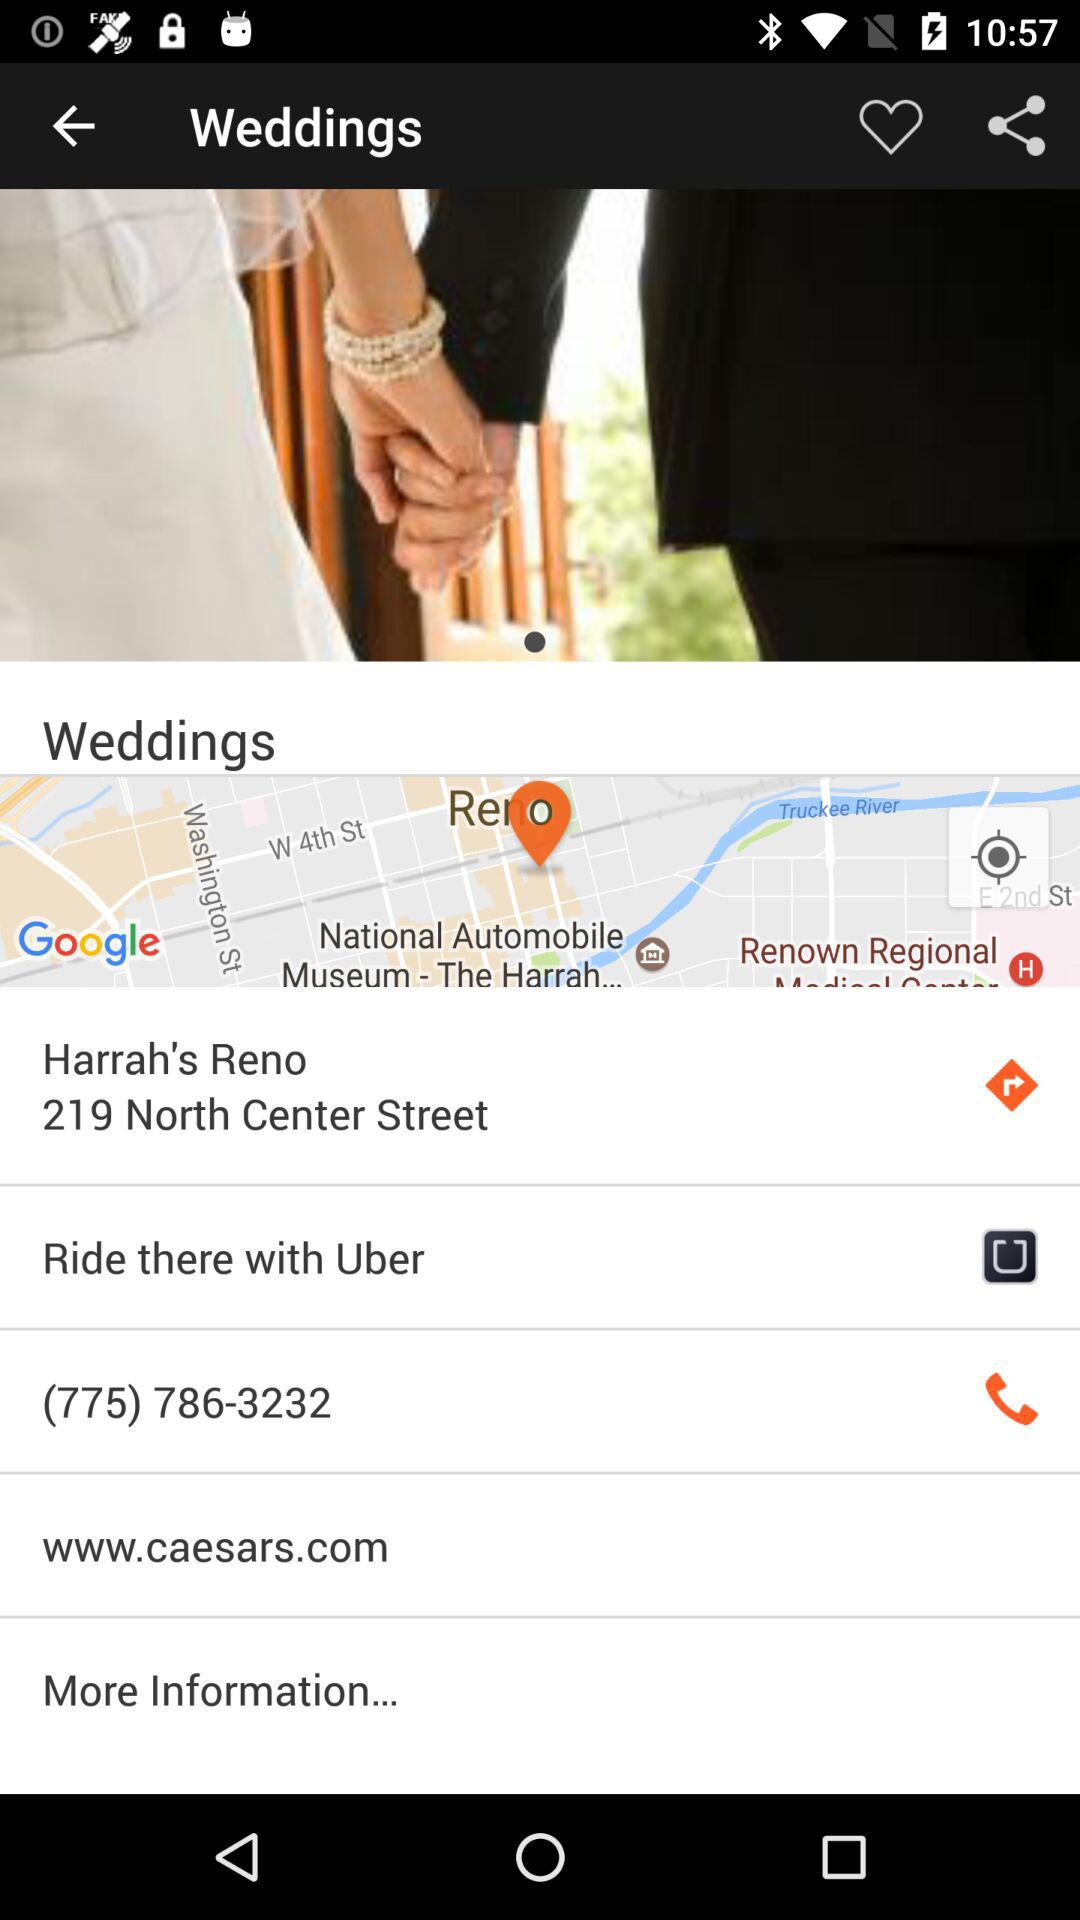What is the contact number? The contact number is (775) 786-3232. 